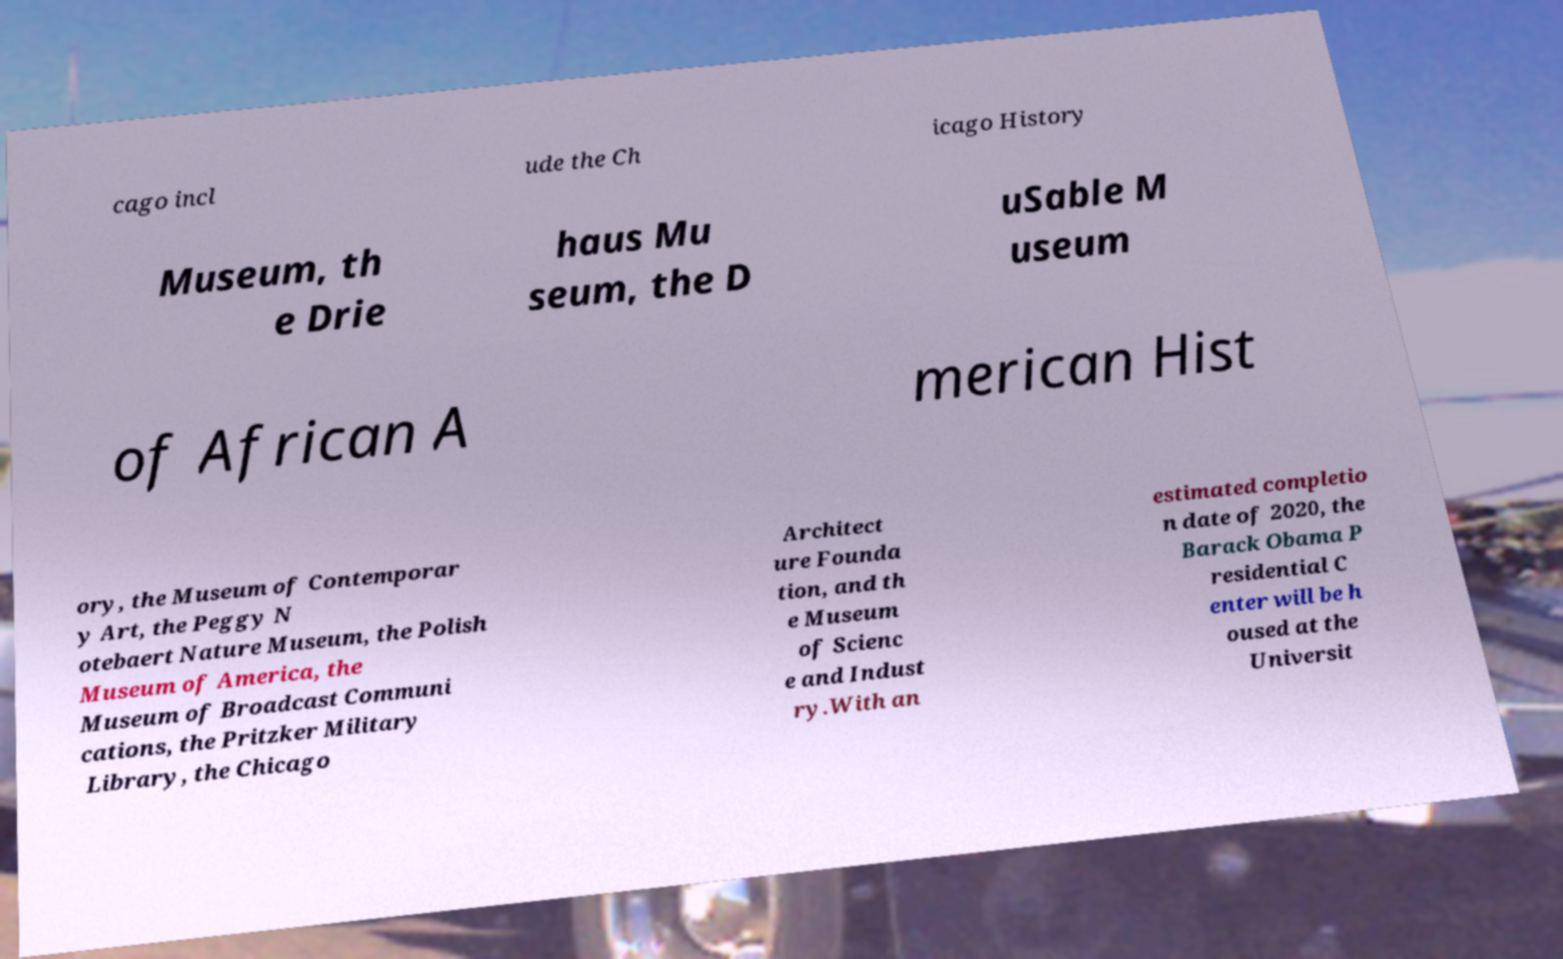Can you read and provide the text displayed in the image?This photo seems to have some interesting text. Can you extract and type it out for me? cago incl ude the Ch icago History Museum, th e Drie haus Mu seum, the D uSable M useum of African A merican Hist ory, the Museum of Contemporar y Art, the Peggy N otebaert Nature Museum, the Polish Museum of America, the Museum of Broadcast Communi cations, the Pritzker Military Library, the Chicago Architect ure Founda tion, and th e Museum of Scienc e and Indust ry.With an estimated completio n date of 2020, the Barack Obama P residential C enter will be h oused at the Universit 